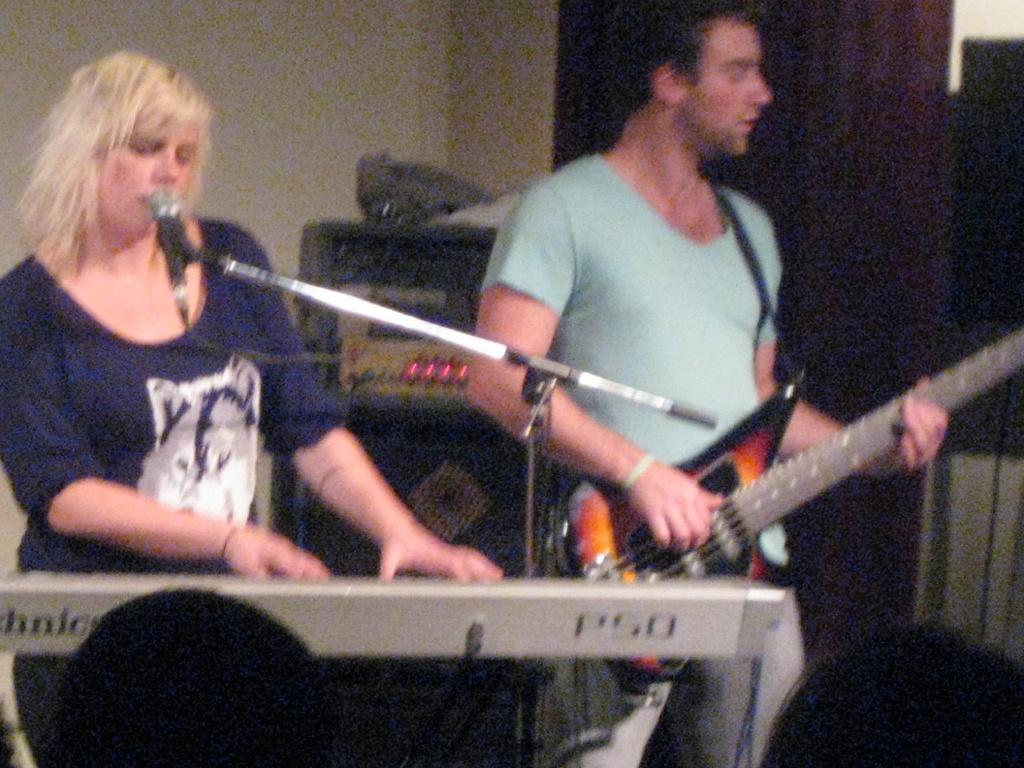How would you summarize this image in a sentence or two? In this picture there are two people at the left side of the image, those who are singing the songs, there is a piano in front of the lady and a mic the boy who is standing at the right side of the image is holding a guitar in his hand. 